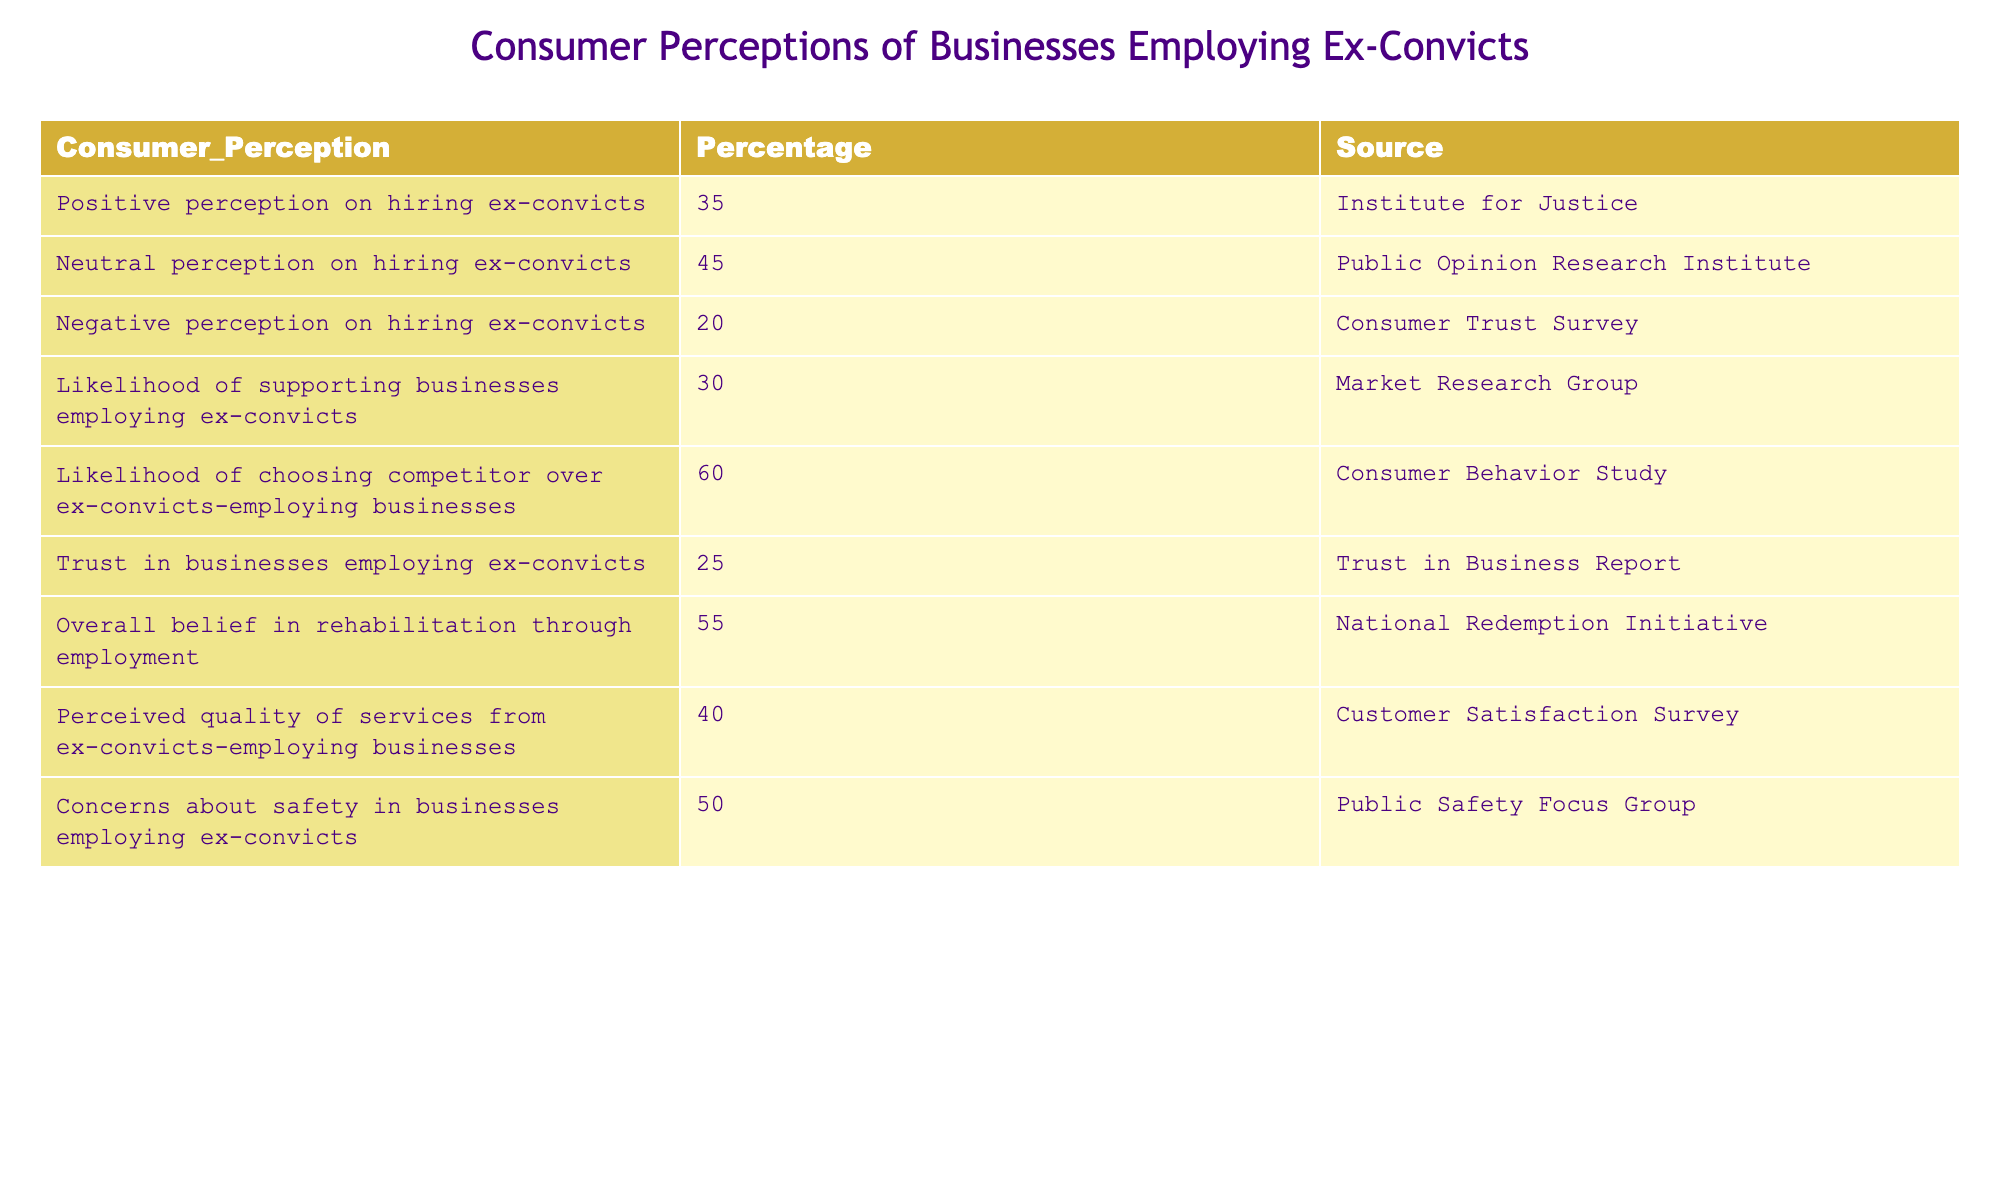What percentage of consumers have a positive perception of businesses employing ex-convicts? The table shows that 35% of consumers have a positive perception of businesses employing ex-convicts, as indicated in the row corresponding to "Positive perception on hiring ex-convicts."
Answer: 35% What is the percentage of consumers who have a neutral perception of such businesses? According to the table, 45% of consumers report a neutral perception, found in the row labeled "Neutral perception on hiring ex-convicts."
Answer: 45% What is the likelihood of choosing a competitor over businesses that employ ex-convicts? The table indicates that the likelihood of choosing a competitor over ex-convicts-employing businesses is 60%, which is detailed in the row "Likelihood of choosing competitor over ex-convicts-employing businesses."
Answer: 60% What is the average consumer perception percentage for positive and negative views of hiring ex-convicts? To find the average, we first gather the percentages for positive (35%) and negative (20%) perceptions. We then calculate the average: (35 + 20) / 2 = 27.5. Therefore, the average perception percentage for positive and negative views is 27.5%.
Answer: 27.5% Is there greater consumer concern about safety when businesses employ ex-convicts compared to trust in those businesses? The table shows that 50% of consumers express concerns about safety in businesses employing ex-convicts (from the row "Concerns about safety in businesses employing ex-convicts") and 25% trust these businesses ("Trust in businesses employing ex-convicts"). Since 50% is greater than 25%, the answer is yes, there is greater concern about safety.
Answer: Yes If 55% of consumers believe in rehabilitation through employment, what is the difference in percentage between this belief and the trust level in businesses employing ex-convicts? From the table, we see that 55% believe in rehabilitation (from the row "Overall belief in rehabilitation through employment") and 25% trust businesses employing ex-convicts. The difference is calculated as 55 - 25 = 30. Thus, there is a 30% difference between these two measures.
Answer: 30% What is the percentage of consumers who perceive lower service quality from businesses that employ ex-convicts compared to the overall percentage who have negative perceptions? The table indicates that 40% perceive the quality of services from ex-convicts-employing businesses as low ("Perceived quality of services from ex-convicts-employing businesses") and 20% have a negative perception overall ("Negative perception on hiring ex-convicts"). Since 40% is higher than 20%, the conclusion is that a greater percentage perceives some quality issues than those with negative perceptions.
Answer: Yes What is the relationship between the likelihood of supporting businesses employing ex-convicts and the trust in those businesses? The likelihood of supporting businesses employing ex-convicts is noted as 30% ("Likelihood of supporting businesses employing ex-convicts"), while trust in such businesses is indicated as 25% ("Trust in businesses employing ex-convicts"). The likelihood of support is higher than the level of trust, suggesting that while consumers may support these businesses, they do not fully trust them.
Answer: Higher support than trust 